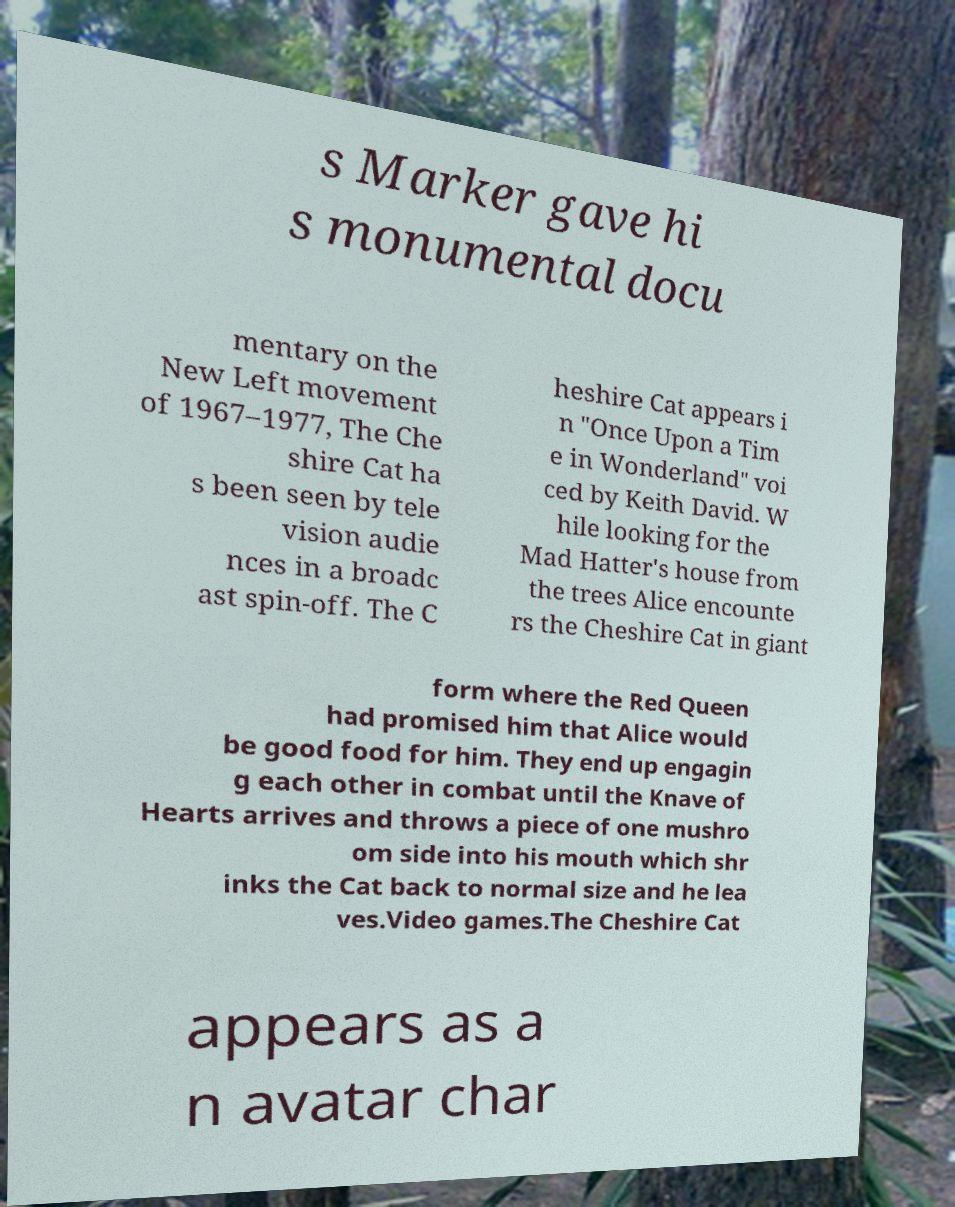There's text embedded in this image that I need extracted. Can you transcribe it verbatim? s Marker gave hi s monumental docu mentary on the New Left movement of 1967–1977, The Che shire Cat ha s been seen by tele vision audie nces in a broadc ast spin-off. The C heshire Cat appears i n "Once Upon a Tim e in Wonderland" voi ced by Keith David. W hile looking for the Mad Hatter's house from the trees Alice encounte rs the Cheshire Cat in giant form where the Red Queen had promised him that Alice would be good food for him. They end up engagin g each other in combat until the Knave of Hearts arrives and throws a piece of one mushro om side into his mouth which shr inks the Cat back to normal size and he lea ves.Video games.The Cheshire Cat appears as a n avatar char 